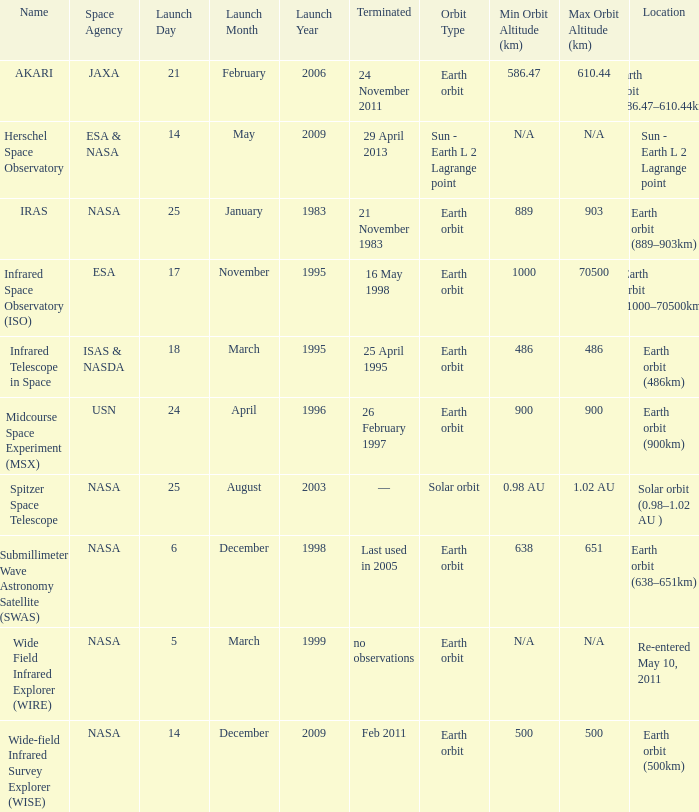Which space agency launched the herschel space observatory? ESA & NASA. 